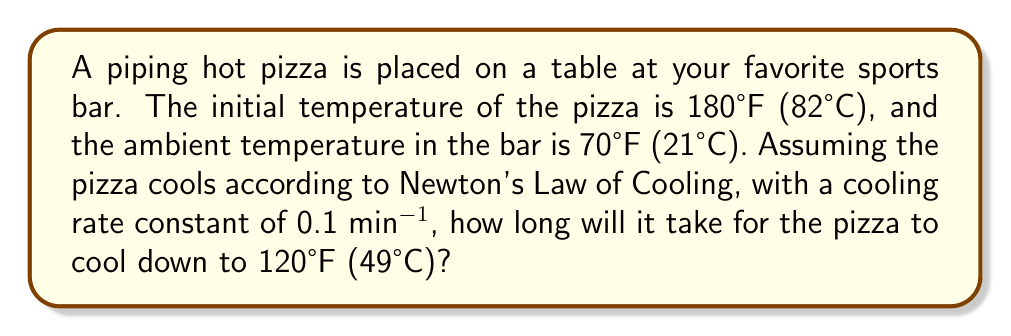Provide a solution to this math problem. Let's approach this step-by-step using Newton's Law of Cooling:

1) Newton's Law of Cooling is given by:
   $$\frac{dT}{dt} = -k(T - T_a)$$
   where $T$ is the temperature of the object, $T_a$ is the ambient temperature, $t$ is time, and $k$ is the cooling rate constant.

2) The solution to this differential equation is:
   $$T(t) = T_a + (T_0 - T_a)e^{-kt}$$
   where $T_0$ is the initial temperature.

3) We're given:
   $T_0 = 180°F$
   $T_a = 70°F$
   $k = 0.1$ min^(-1)
   We want to find $t$ when $T(t) = 120°F$

4) Plugging these values into our equation:
   $$120 = 70 + (180 - 70)e^{-0.1t}$$

5) Simplify:
   $$50 = 110e^{-0.1t}$$

6) Divide both sides by 110:
   $$\frac{5}{11} = e^{-0.1t}$$

7) Take the natural log of both sides:
   $$\ln(\frac{5}{11}) = -0.1t$$

8) Solve for $t$:
   $$t = -\frac{\ln(\frac{5}{11})}{0.1} \approx 7.82 \text{ minutes}$$
Answer: $7.82$ minutes 